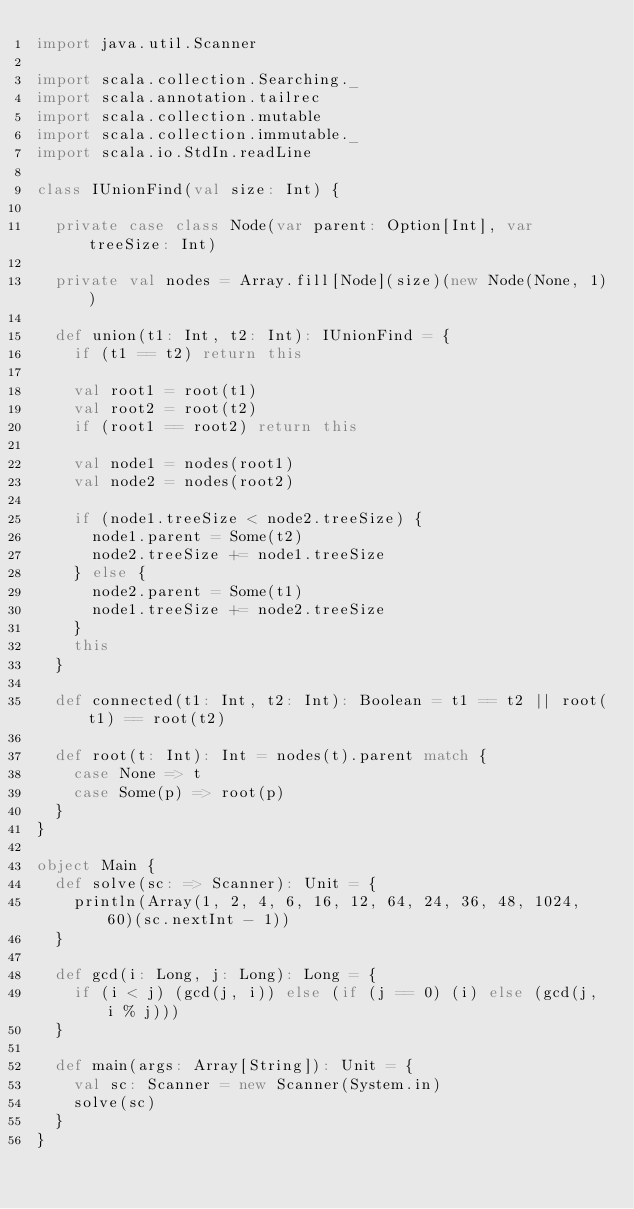Convert code to text. <code><loc_0><loc_0><loc_500><loc_500><_Scala_>import java.util.Scanner

import scala.collection.Searching._
import scala.annotation.tailrec
import scala.collection.mutable
import scala.collection.immutable._
import scala.io.StdIn.readLine

class IUnionFind(val size: Int) {

  private case class Node(var parent: Option[Int], var treeSize: Int)

  private val nodes = Array.fill[Node](size)(new Node(None, 1))

  def union(t1: Int, t2: Int): IUnionFind = {
    if (t1 == t2) return this

    val root1 = root(t1)
    val root2 = root(t2)
    if (root1 == root2) return this

    val node1 = nodes(root1)
    val node2 = nodes(root2)

    if (node1.treeSize < node2.treeSize) {
      node1.parent = Some(t2)
      node2.treeSize += node1.treeSize
    } else {
      node2.parent = Some(t1)
      node1.treeSize += node2.treeSize
    }
    this
  }

  def connected(t1: Int, t2: Int): Boolean = t1 == t2 || root(t1) == root(t2)

  def root(t: Int): Int = nodes(t).parent match {
    case None => t
    case Some(p) => root(p)
  }
}

object Main {
  def solve(sc: => Scanner): Unit = {
    println(Array(1, 2, 4, 6, 16, 12, 64, 24, 36, 48, 1024, 60)(sc.nextInt - 1))
  }

  def gcd(i: Long, j: Long): Long = {
    if (i < j) (gcd(j, i)) else (if (j == 0) (i) else (gcd(j, i % j)))
  }

  def main(args: Array[String]): Unit = {
    val sc: Scanner = new Scanner(System.in)
    solve(sc)
  }
}
</code> 